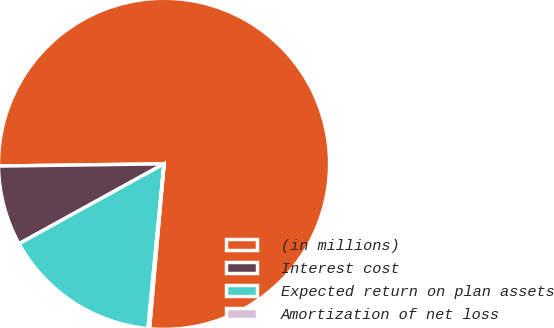<chart> <loc_0><loc_0><loc_500><loc_500><pie_chart><fcel>(in millions)<fcel>Interest cost<fcel>Expected return on plan assets<fcel>Amortization of net loss<nl><fcel>76.61%<fcel>7.8%<fcel>15.44%<fcel>0.15%<nl></chart> 